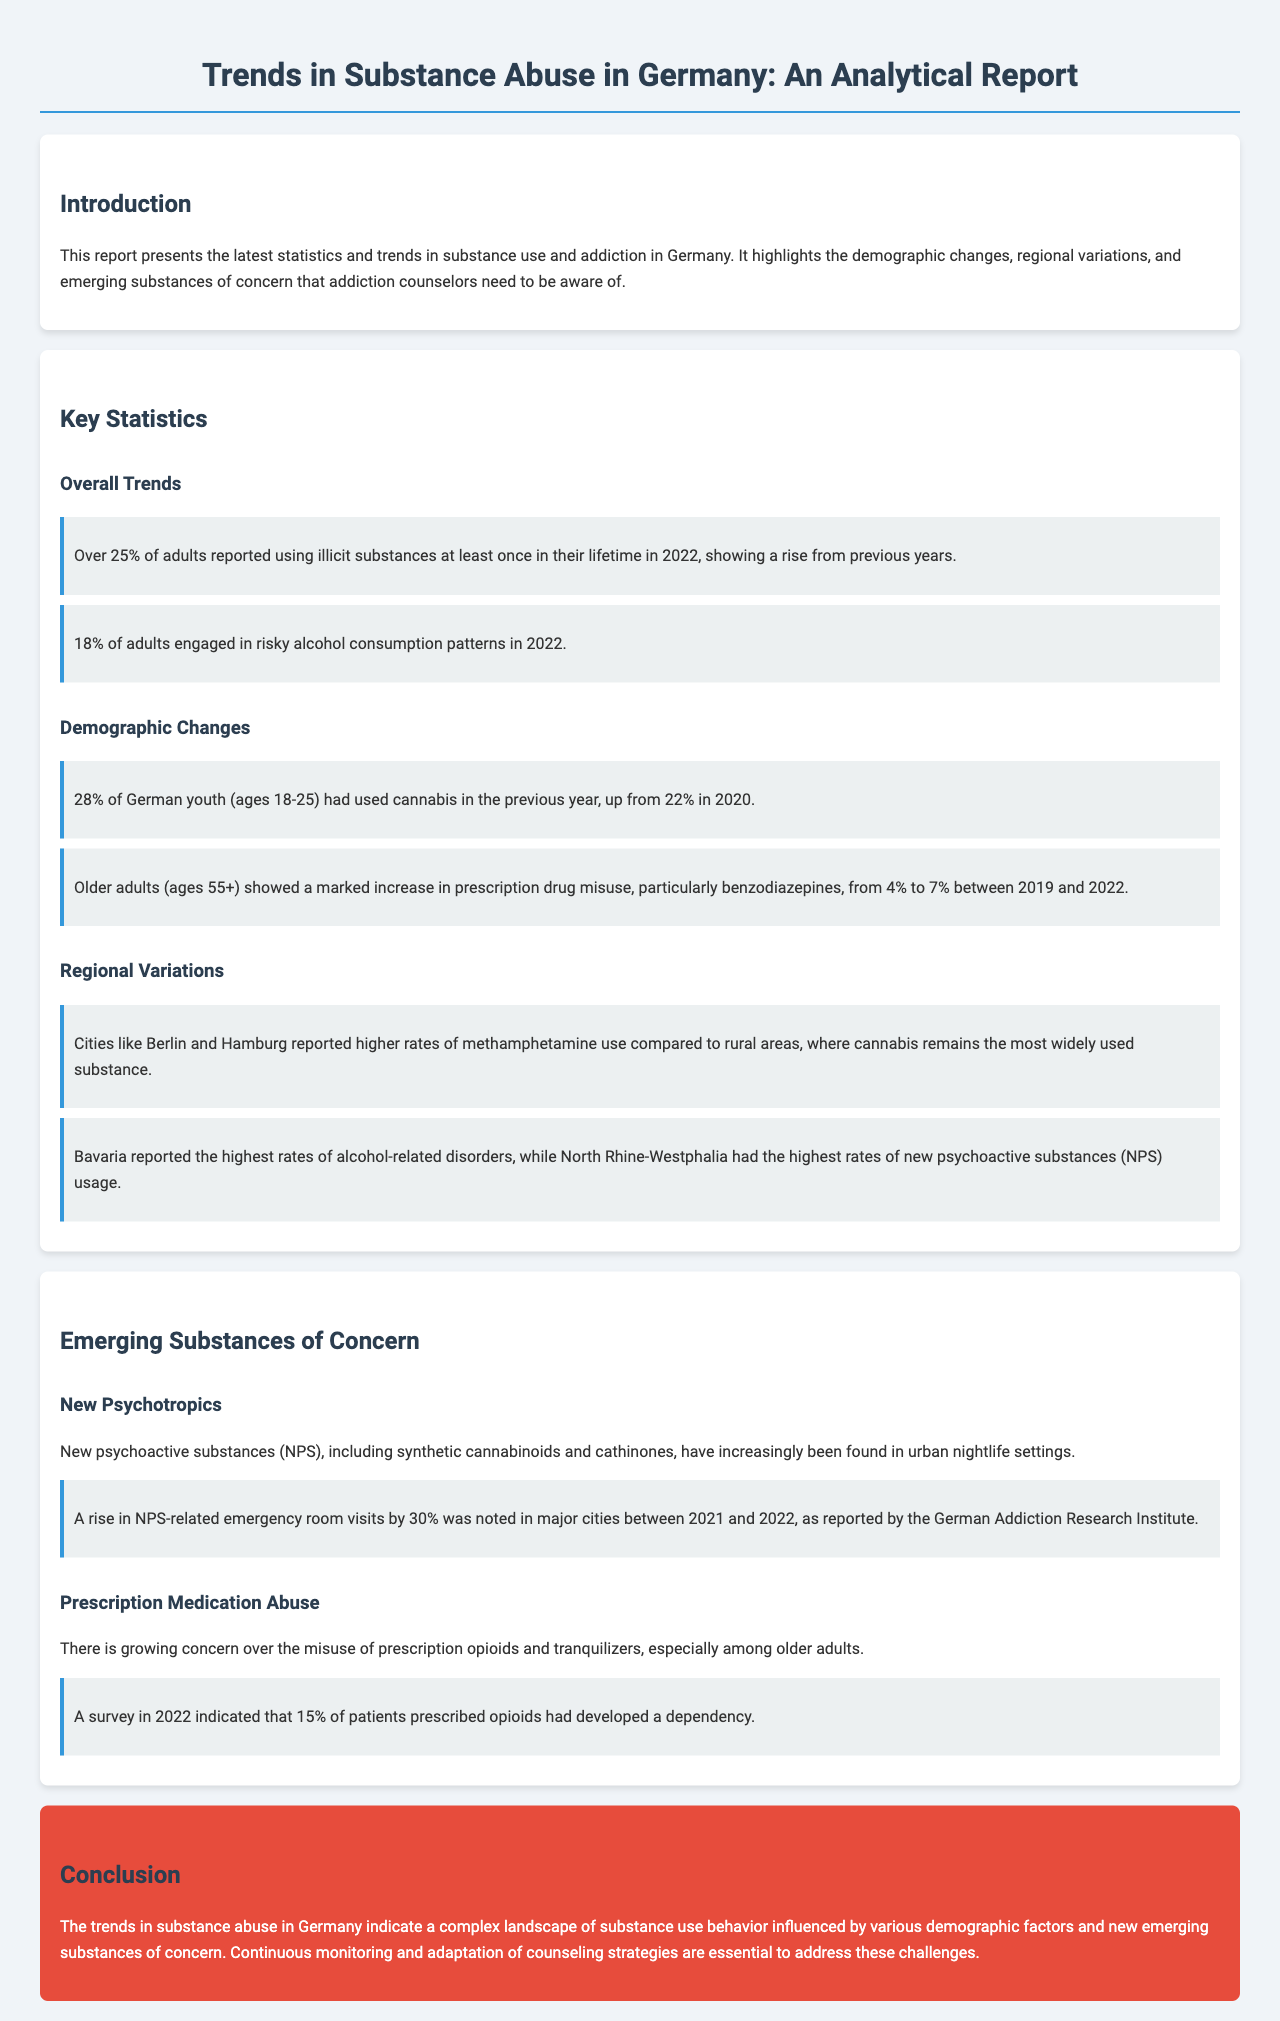What percentage of adults reported using illicit substances in their lifetime in 2022? The document states that over 25% of adults reported using illicit substances at least once in their lifetime in 2022.
Answer: 25% What is the percentage of German youth who used cannabis in the past year? According to the report, 28% of German youth (ages 18-25) had used cannabis in the previous year.
Answer: 28% Which city reported higher rates of methamphetamine use? The document mentions that cities like Berlin and Hamburg reported higher rates of methamphetamine use compared to rural areas.
Answer: Berlin and Hamburg What was the increase in emergency room visits related to NPS in major cities? The report notes that there was a rise in NPS-related emergency room visits by 30% in major cities between 2021 and 2022.
Answer: 30% What trend was observed in prescription drug misuse among older adults from 2019 to 2022? The document indicates that older adults (ages 55+) showed an increase in prescription drug misuse, particularly benzodiazepines, from 4% to 7% between 2019 and 2022.
Answer: from 4% to 7% What substance showed the highest rates of usage in rural areas? The report states that cannabis remains the most widely used substance in rural areas.
Answer: Cannabis What percentage of patients prescribed opioids developed a dependency? A survey indicated that 15% of patients prescribed opioids had developed a dependency.
Answer: 15% Which region had the highest rates of alcohol-related disorders? The document mentions that Bavaria reported the highest rates of alcohol-related disorders.
Answer: Bavaria 